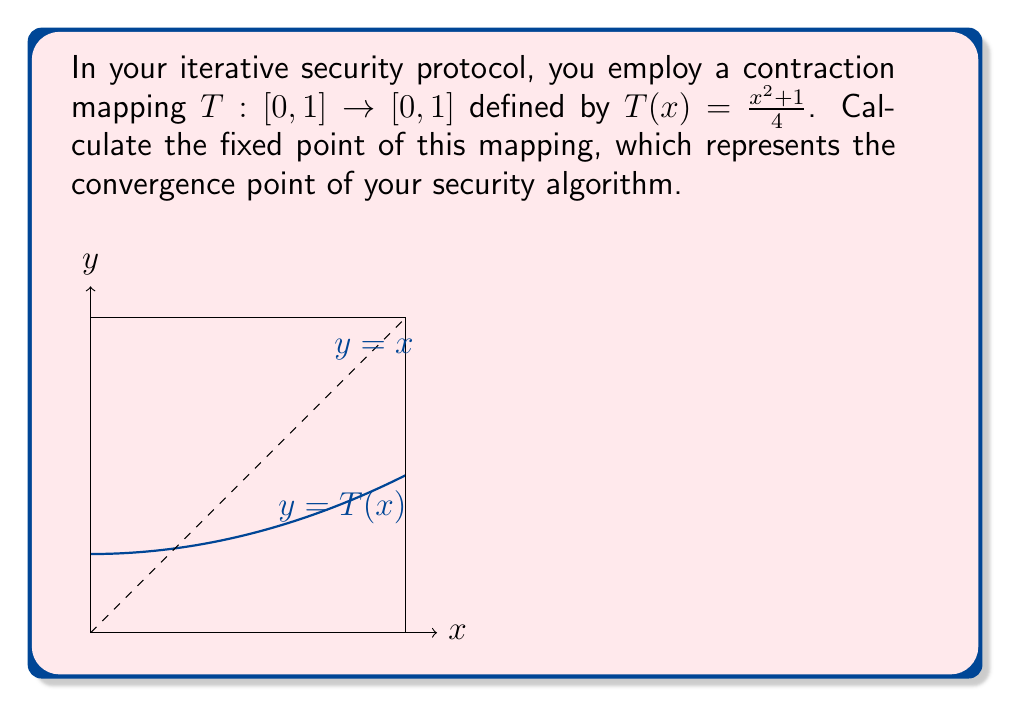What is the answer to this math problem? To find the fixed point of the contraction mapping $T(x) = \frac{x^2 + 1}{4}$, we need to solve the equation $T(x) = x$:

1) Set up the equation:
   $$\frac{x^2 + 1}{4} = x$$

2) Multiply both sides by 4:
   $$x^2 + 1 = 4x$$

3) Rearrange to standard quadratic form:
   $$x^2 - 4x + 1 = 0$$

4) Use the quadratic formula $x = \frac{-b \pm \sqrt{b^2 - 4ac}}{2a}$:
   $$x = \frac{4 \pm \sqrt{16 - 4(1)(1)}}{2(1)} = \frac{4 \pm \sqrt{12}}{2}$$

5) Simplify:
   $$x = 2 \pm \sqrt{3}$$

6) Since $T: [0,1] \rightarrow [0,1]$, we only consider the solution in $[0,1]$:
   $$x = 2 - \sqrt{3} \approx 0.2679$$

7) Verify that this is indeed a contraction mapping:
   For $x, y \in [0,1]$, $|T(x) - T(y)| = |\frac{x^2-y^2}{4}| = \frac{|x+y|}{4}|x-y| \leq \frac{1}{2}|x-y|$
   
   The Lipschitz constant $L = \frac{1}{2} < 1$, confirming it's a contraction mapping.

Therefore, the fixed point of the contraction mapping is $2 - \sqrt{3}$.
Answer: $2 - \sqrt{3}$ 